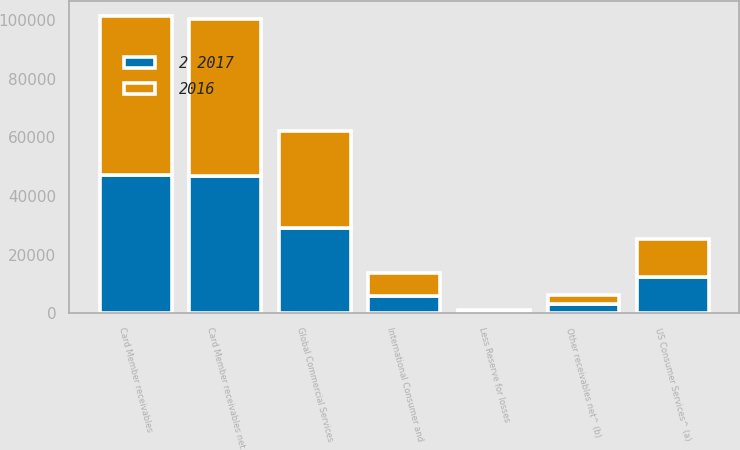Convert chart. <chart><loc_0><loc_0><loc_500><loc_500><stacked_bar_chart><ecel><fcel>US Consumer Services^ (a)<fcel>International Consumer and<fcel>Global Commercial Services<fcel>Card Member receivables<fcel>Less Reserve for losses<fcel>Card Member receivables net<fcel>Other receivables net^ (b)<nl><fcel>2016<fcel>13143<fcel>7803<fcel>33101<fcel>54047<fcel>521<fcel>53526<fcel>3163<nl><fcel>2 2017<fcel>12302<fcel>5966<fcel>29040<fcel>47308<fcel>467<fcel>46841<fcel>3232<nl></chart> 